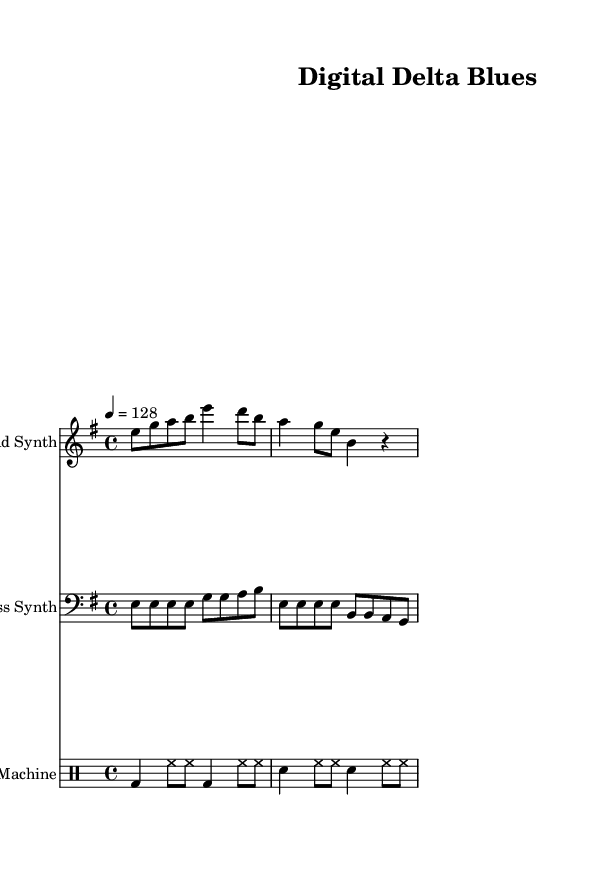What is the key signature of this music? The key signature is e minor, which has one sharp (F#) and is indicated at the beginning of the staff with the corresponding sharp symbol.
Answer: e minor What is the time signature of the piece? The time signature is 4/4, which means there are four beats in each measure and a quarter note gets one beat. This is displayed at the beginning of the score in the time signature notation.
Answer: 4/4 What is the tempo marking for this piece? The tempo marking is 128 beats per minute as indicated by the tempo marking "4 = 128" at the beginning of the score.
Answer: 128 How many measures are in the lead synth part? The lead synth part contains four measures, as counted by the number of groups of notes and rests between the vertical bar lines indicating the end of a measure.
Answer: four What type of rhythm is most prevalent in the bass synth part? The bass synth part features steady eighth notes followed by quarter notes, which creates a consistent rhythmic pulse typical in house music.
Answer: steady eighth notes What is the role of the drum pattern in this piece? The drum pattern establishes the groove and maintains the rhythmic foundation of the track, which is fundamental in house music styles. It typically consists of a bass drum and snare on alternating beats, providing a danceable rhythm.
Answer: groove How does the lead synth complement the rhythmic patterns of the bass synth? The lead synth complements the bass synth by providing melodic lines that interlock rhythmically with the bass notes, often playing syncopated rhythms that enhance the overall texture of the music.
Answer: interlock rhythmically 